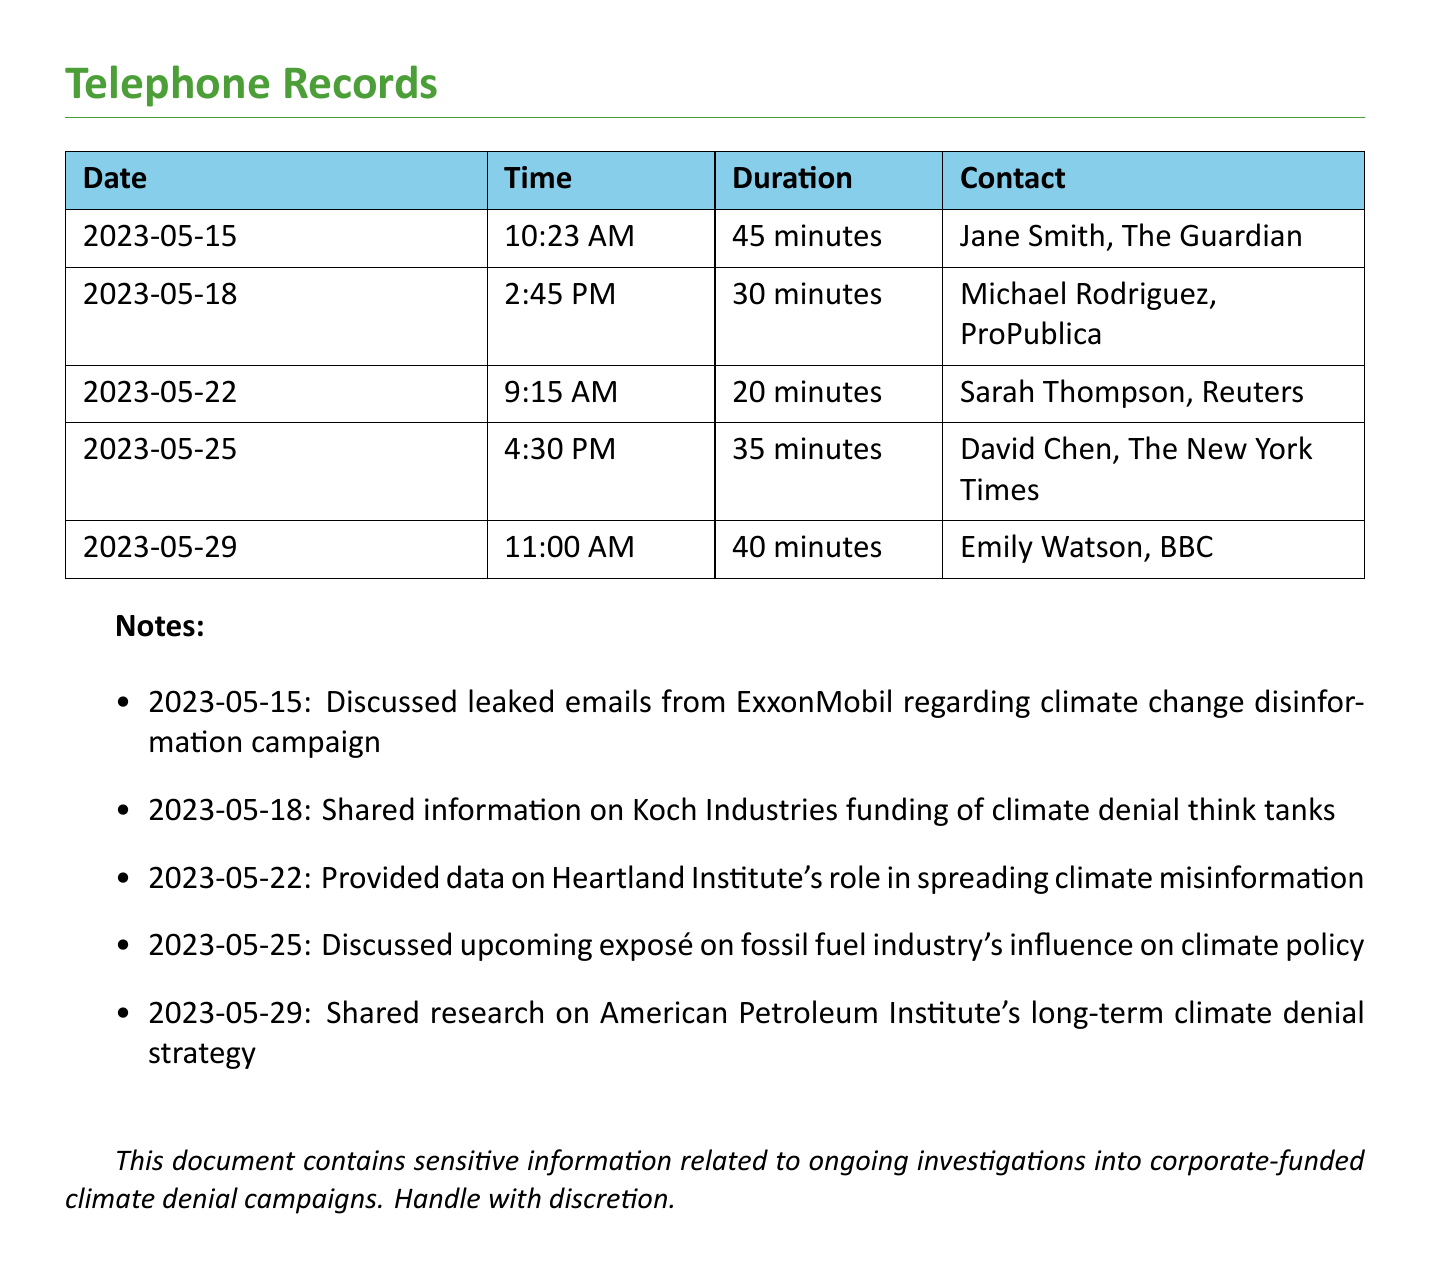What is the date of the first call? The first call took place on May 15, 2023.
Answer: May 15, 2023 Who is the contact for the call on May 18? The contact for the call on May 18 is Michael Rodriguez.
Answer: Michael Rodriguez How long was the call with Jane Smith? The duration of the call with Jane Smith was 45 minutes.
Answer: 45 minutes What organization was discussed in relation to climate disinformation on May 15? The organization discussed was ExxonMobil.
Answer: ExxonMobil How many total calls are recorded in the document? There are five calls recorded in the document.
Answer: Five Which media outlet did Sarah Thompson represent? Sarah Thompson represented Reuters.
Answer: Reuters What was the focus of the conversation on May 25? The conversation on May 25 focused on an exposé of the fossil fuel industry's influence on climate policy.
Answer: Exposé on fossil fuel industry's influence on climate policy Which call had the shortest duration? The call with Sarah Thompson had the shortest duration of 20 minutes.
Answer: 20 minutes What is one of the topics covered in the notes related to the calls? One of the topics covered is the Koch Industries funding of climate denial think tanks.
Answer: Koch Industries funding of climate denial think tanks 